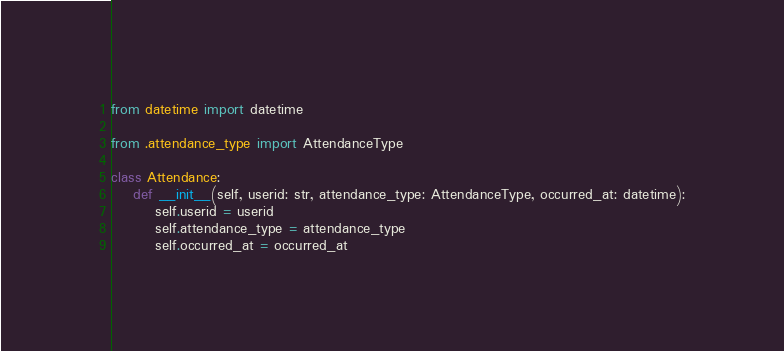Convert code to text. <code><loc_0><loc_0><loc_500><loc_500><_Python_>from datetime import datetime

from .attendance_type import AttendanceType

class Attendance:
    def __init__(self, userid: str, attendance_type: AttendanceType, occurred_at: datetime):
        self.userid = userid
        self.attendance_type = attendance_type 
        self.occurred_at = occurred_at</code> 